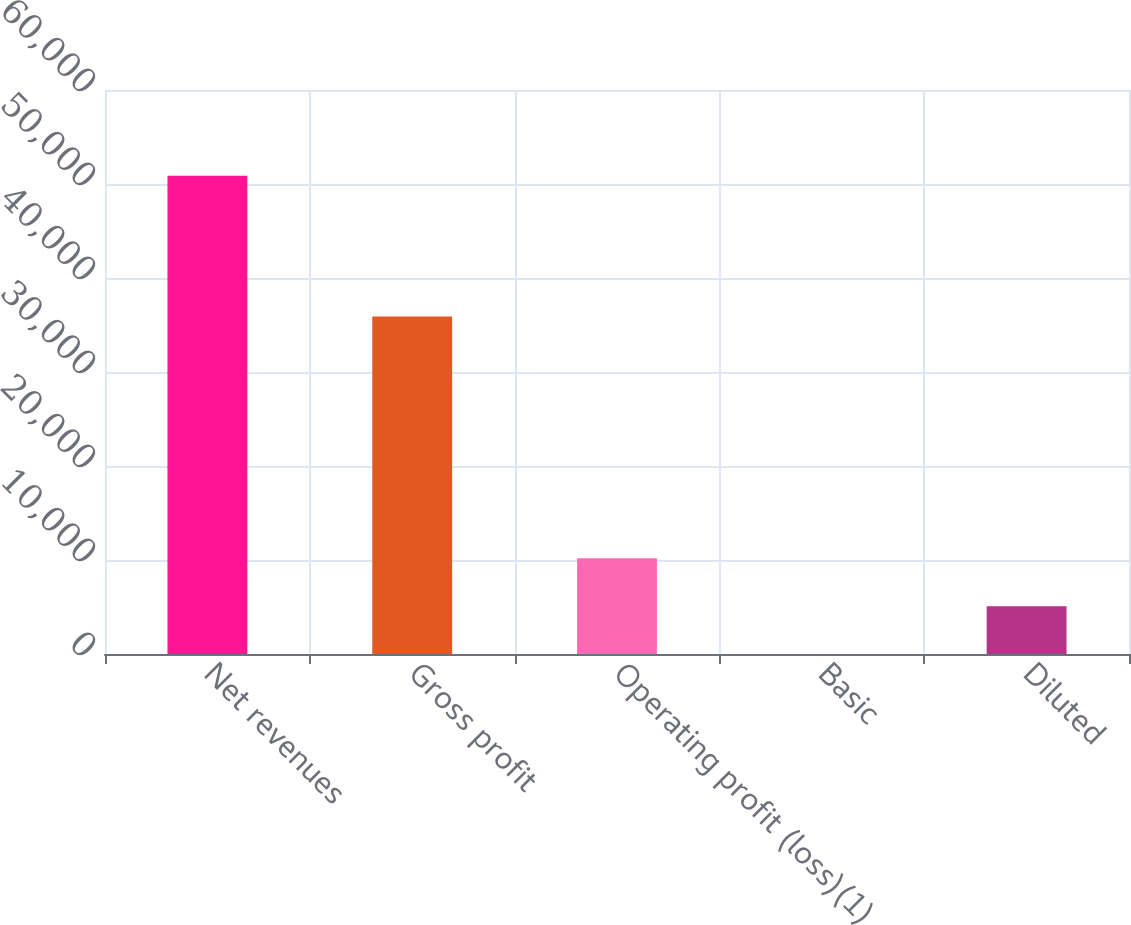Convert chart to OTSL. <chart><loc_0><loc_0><loc_500><loc_500><bar_chart><fcel>Net revenues<fcel>Gross profit<fcel>Operating profit (loss)(1)<fcel>Basic<fcel>Diluted<nl><fcel>50866<fcel>35891<fcel>10173.2<fcel>0.02<fcel>5086.62<nl></chart> 